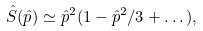Convert formula to latex. <formula><loc_0><loc_0><loc_500><loc_500>\hat { S } ( \hat { p } ) \simeq \hat { p } ^ { 2 } ( 1 - \hat { p } ^ { 2 } / 3 + \dots ) ,</formula> 